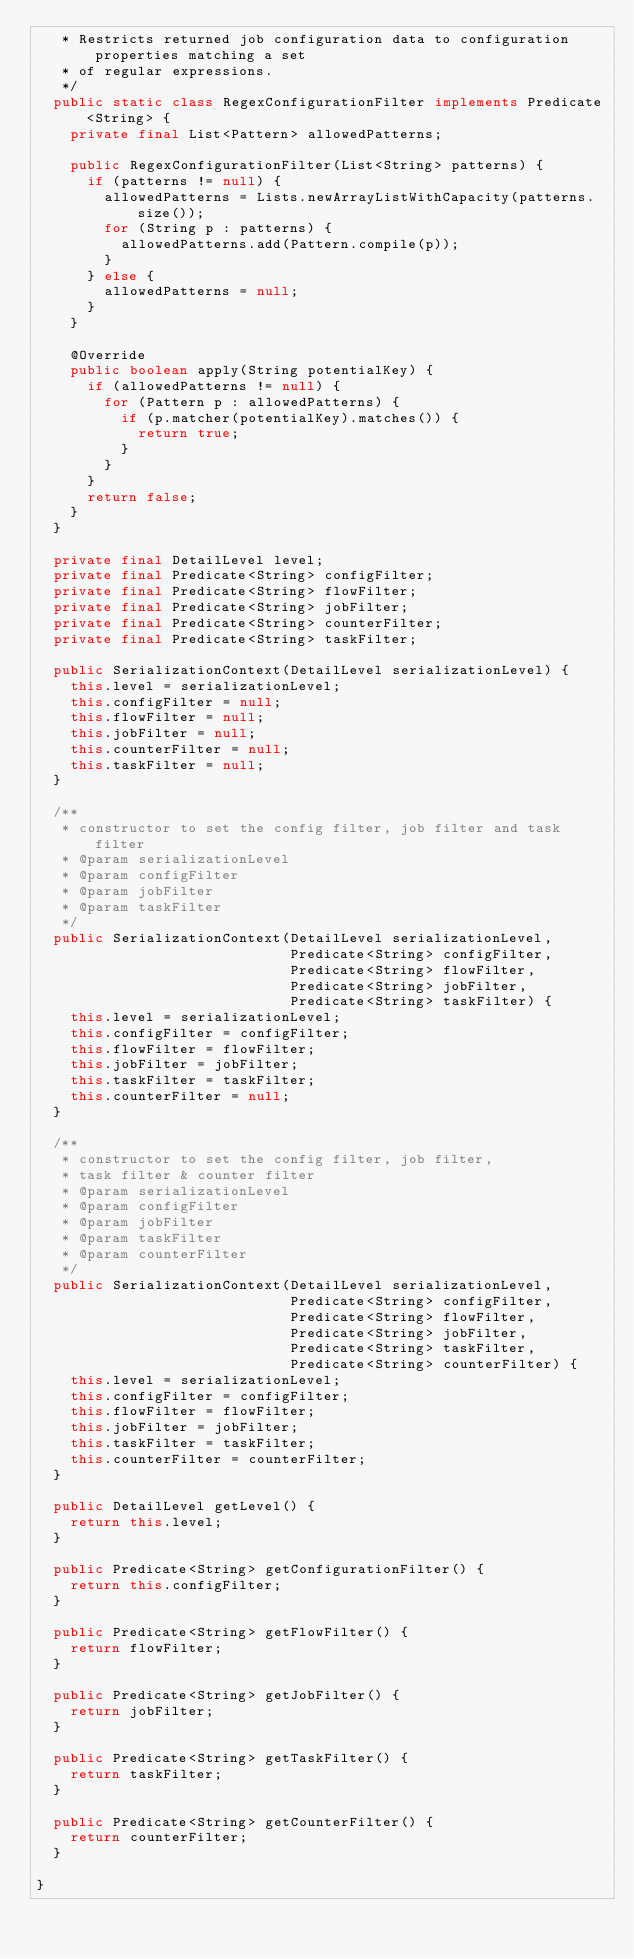Convert code to text. <code><loc_0><loc_0><loc_500><loc_500><_Java_>   * Restricts returned job configuration data to configuration properties matching a set
   * of regular expressions.
   */
  public static class RegexConfigurationFilter implements Predicate<String> {
    private final List<Pattern> allowedPatterns;

    public RegexConfigurationFilter(List<String> patterns) {
      if (patterns != null) {
        allowedPatterns = Lists.newArrayListWithCapacity(patterns.size());
        for (String p : patterns) {
          allowedPatterns.add(Pattern.compile(p));
        }
      } else {
        allowedPatterns = null;
      }
    }

    @Override
    public boolean apply(String potentialKey) {
      if (allowedPatterns != null) {
        for (Pattern p : allowedPatterns) {
          if (p.matcher(potentialKey).matches()) {
            return true;
          }
        }
      }
      return false;
    }
  }

  private final DetailLevel level;
  private final Predicate<String> configFilter;
  private final Predicate<String> flowFilter;
  private final Predicate<String> jobFilter;
  private final Predicate<String> counterFilter;
  private final Predicate<String> taskFilter;

  public SerializationContext(DetailLevel serializationLevel) {
    this.level = serializationLevel;
    this.configFilter = null;
    this.flowFilter = null;
    this.jobFilter = null;
    this.counterFilter = null;
    this.taskFilter = null;
  }

  /**
   * constructor to set the config filter, job filter and task filter
   * @param serializationLevel
   * @param configFilter
   * @param jobFilter
   * @param taskFilter
   */
  public SerializationContext(DetailLevel serializationLevel,
                              Predicate<String> configFilter,
                              Predicate<String> flowFilter,
                              Predicate<String> jobFilter,
                              Predicate<String> taskFilter) {
    this.level = serializationLevel;
    this.configFilter = configFilter;
    this.flowFilter = flowFilter;
    this.jobFilter = jobFilter;
    this.taskFilter = taskFilter;
    this.counterFilter = null;
  }

  /**
   * constructor to set the config filter, job filter,
   * task filter & counter filter
   * @param serializationLevel
   * @param configFilter
   * @param jobFilter
   * @param taskFilter
   * @param counterFilter
   */
  public SerializationContext(DetailLevel serializationLevel,
                              Predicate<String> configFilter,
                              Predicate<String> flowFilter,
                              Predicate<String> jobFilter,
                              Predicate<String> taskFilter,
                              Predicate<String> counterFilter) {
    this.level = serializationLevel;
    this.configFilter = configFilter;
    this.flowFilter = flowFilter;
    this.jobFilter = jobFilter;
    this.taskFilter = taskFilter;
    this.counterFilter = counterFilter;
  }

  public DetailLevel getLevel() {
    return this.level;
  }

  public Predicate<String> getConfigurationFilter() {
    return this.configFilter;
  }

  public Predicate<String> getFlowFilter() {
    return flowFilter;
  }

  public Predicate<String> getJobFilter() {
    return jobFilter;
  }

  public Predicate<String> getTaskFilter() {
    return taskFilter;
  }

  public Predicate<String> getCounterFilter() {
    return counterFilter;
  }

}
</code> 